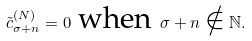<formula> <loc_0><loc_0><loc_500><loc_500>\tilde { c } ^ { ( N ) } _ { \sigma + n } = 0 \text { when } \sigma + n \notin \mathbb { N } .</formula> 